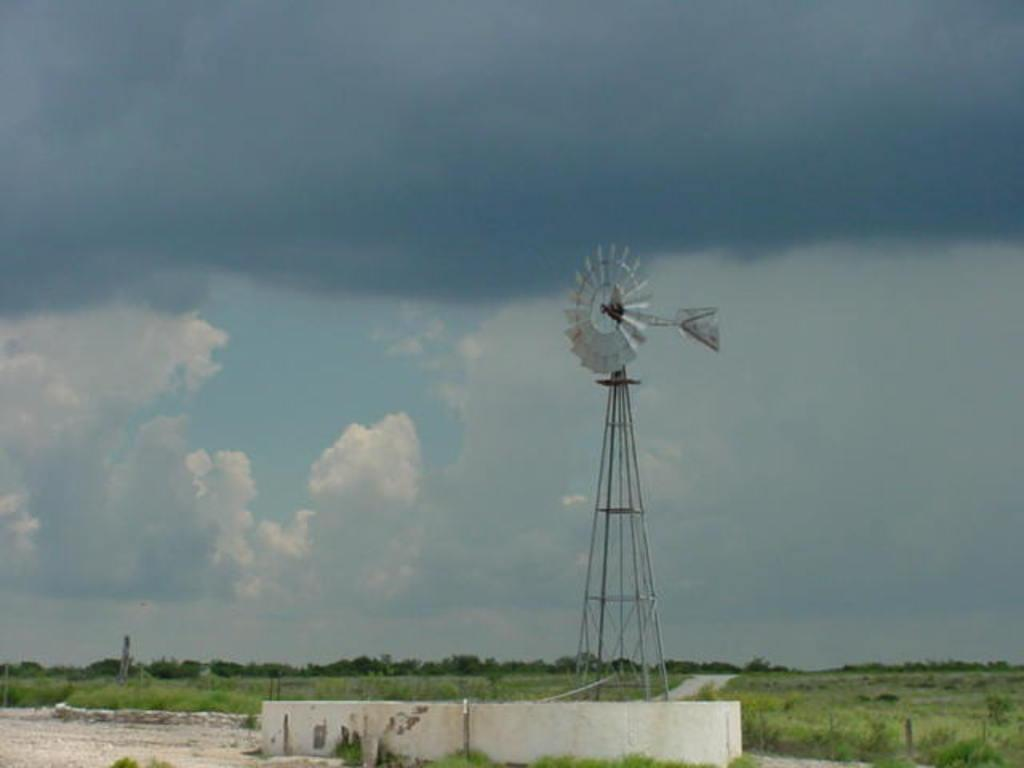What is located at the bottom of the image? There is a wall at the bottom of the image. What can be seen in the background of the image? There are trees in the background of the image. What is the main subject in the middle of the image? There is a windmill in the middle of the image. What is visible behind the windmill? There is a sky visible behind the windmill. How many quarters can be seen in the image? There are no quarters present in the image. What type of quiver is attached to the windmill? There is no quiver present in the image; it features a windmill and other elements mentioned in the facts. 